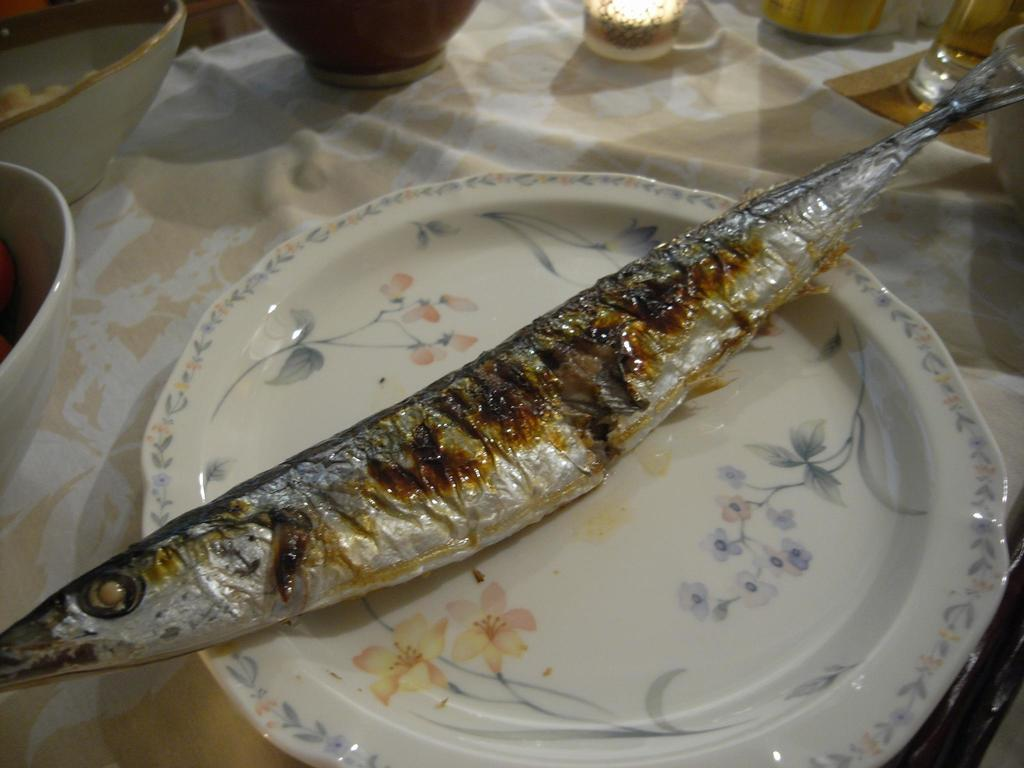What is the main subject of the image? The main subject of the image is a fish on a plate. How is the plate positioned in the image? The plate is placed on a cloth. Are there any other items visible on the cloth? Yes, there are bowls placed at the top on the cloth. What type of silk fabric is used as the ground in the image? There is no silk fabric or ground mentioned in the image; it only features a fish on a plate, a cloth, and bowls. 